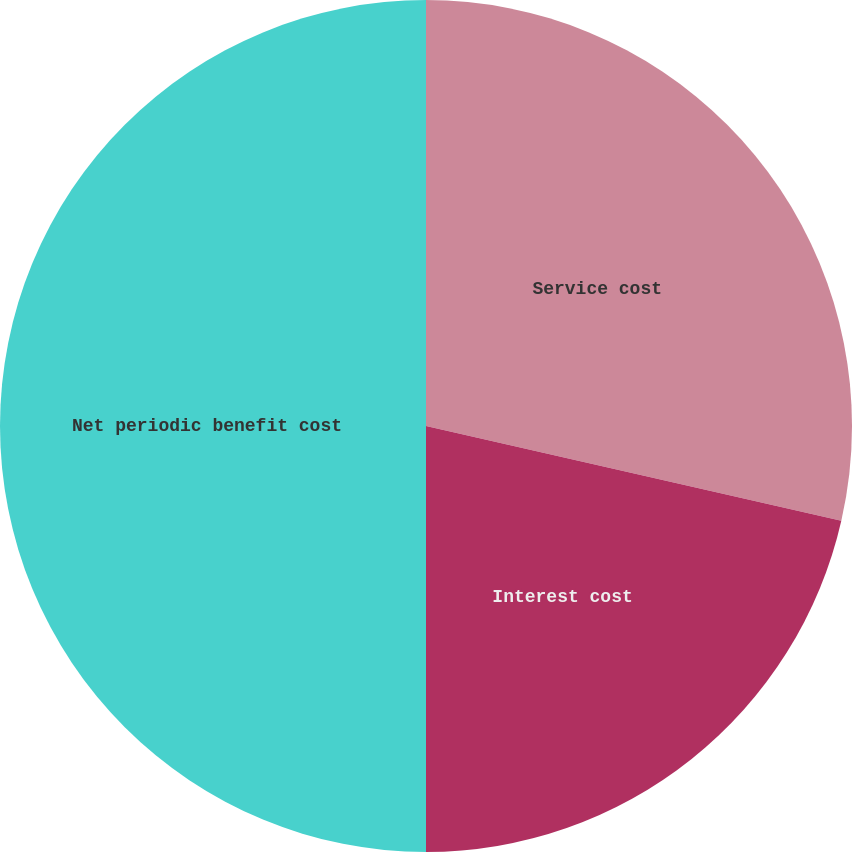Convert chart to OTSL. <chart><loc_0><loc_0><loc_500><loc_500><pie_chart><fcel>Service cost<fcel>Interest cost<fcel>Net periodic benefit cost<nl><fcel>28.57%<fcel>21.43%<fcel>50.0%<nl></chart> 